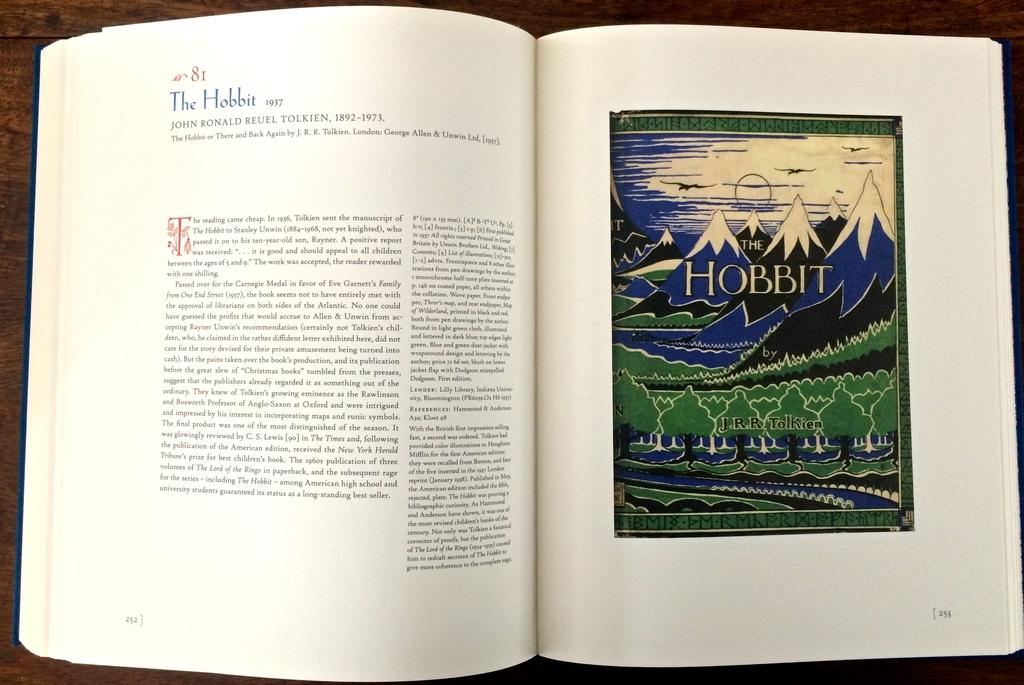<image>
Present a compact description of the photo's key features. the book is open to a page with THE HOBBIT on the right page 